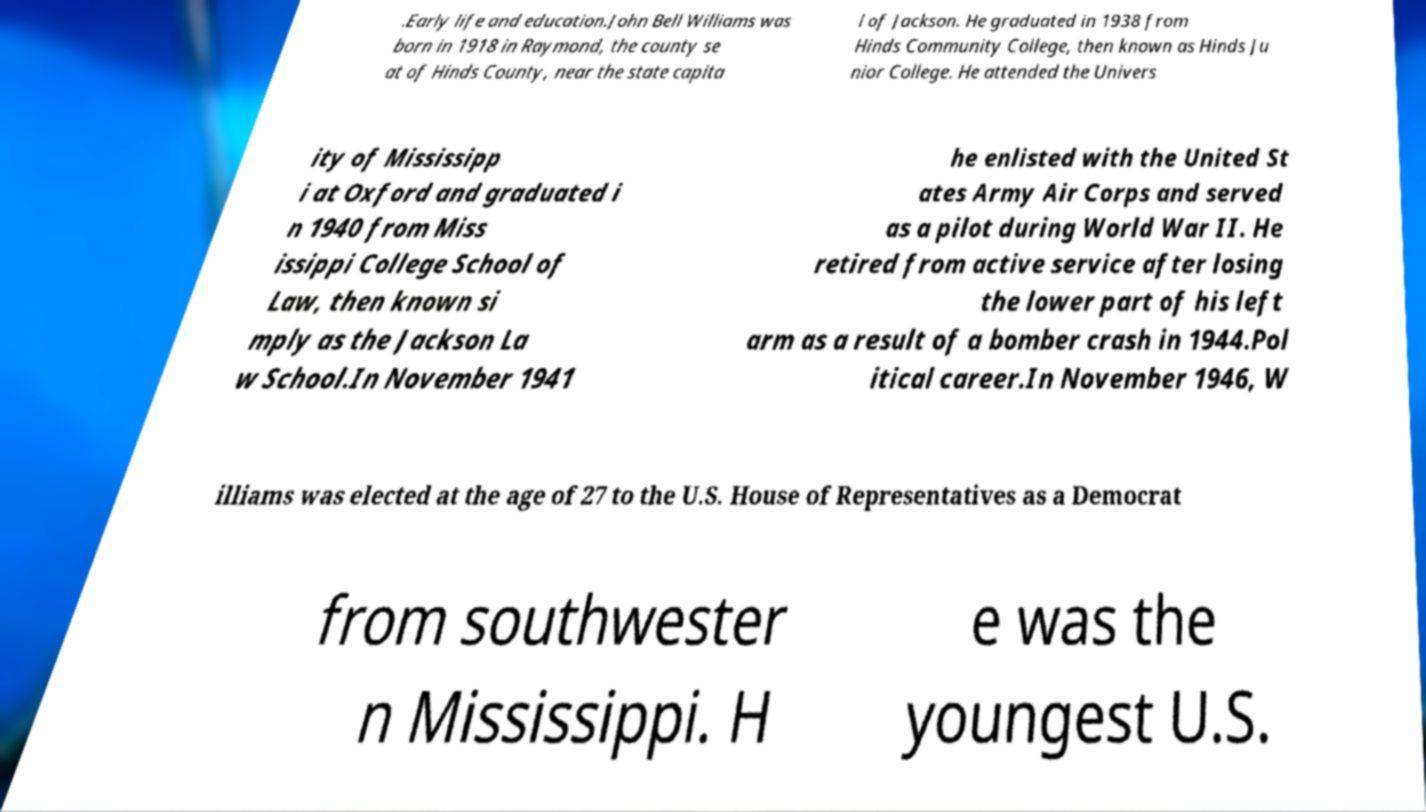Can you accurately transcribe the text from the provided image for me? .Early life and education.John Bell Williams was born in 1918 in Raymond, the county se at of Hinds County, near the state capita l of Jackson. He graduated in 1938 from Hinds Community College, then known as Hinds Ju nior College. He attended the Univers ity of Mississipp i at Oxford and graduated i n 1940 from Miss issippi College School of Law, then known si mply as the Jackson La w School.In November 1941 he enlisted with the United St ates Army Air Corps and served as a pilot during World War II. He retired from active service after losing the lower part of his left arm as a result of a bomber crash in 1944.Pol itical career.In November 1946, W illiams was elected at the age of 27 to the U.S. House of Representatives as a Democrat from southwester n Mississippi. H e was the youngest U.S. 